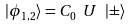<formula> <loc_0><loc_0><loc_500><loc_500>| \phi _ { 1 , 2 } \rangle = C _ { 0 } \text { } U \text { } | \pm \rangle</formula> 